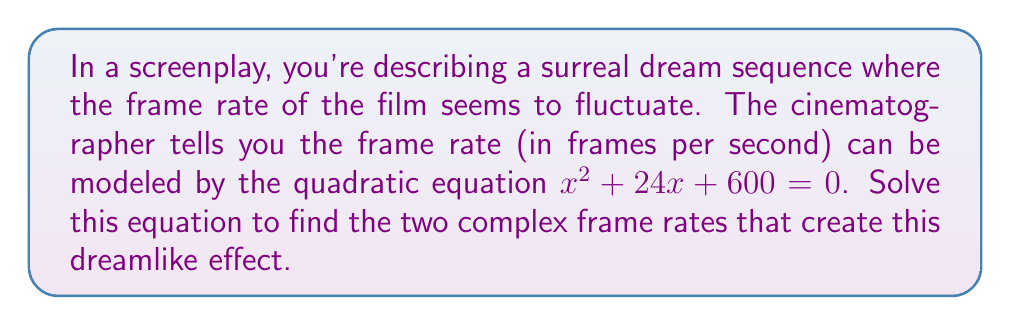Help me with this question. To solve this quadratic equation, we'll use the quadratic formula:

$$x = \frac{-b \pm \sqrt{b^2 - 4ac}}{2a}$$

Where $a = 1$, $b = 24$, and $c = 600$.

Step 1: Calculate the discriminant ($b^2 - 4ac$)
$$b^2 - 4ac = 24^2 - 4(1)(600) = 576 - 2400 = -1824$$

Step 2: Since the discriminant is negative, we know the roots will be complex.

Step 3: Substitute into the quadratic formula
$$x = \frac{-24 \pm \sqrt{-1824}}{2(1)}$$

Step 4: Simplify the square root of a negative number
$$\sqrt{-1824} = \sqrt{1824} \cdot \sqrt{-1} = 24\sqrt{19}i$$

Step 5: Write the final complex solutions
$$x = \frac{-24 \pm 24\sqrt{19}i}{2} = -12 \pm 12\sqrt{19}i$$

Therefore, the two complex frame rates are $-12 + 12\sqrt{19}i$ and $-12 - 12\sqrt{19}i$.
Answer: $-12 \pm 12\sqrt{19}i$ 